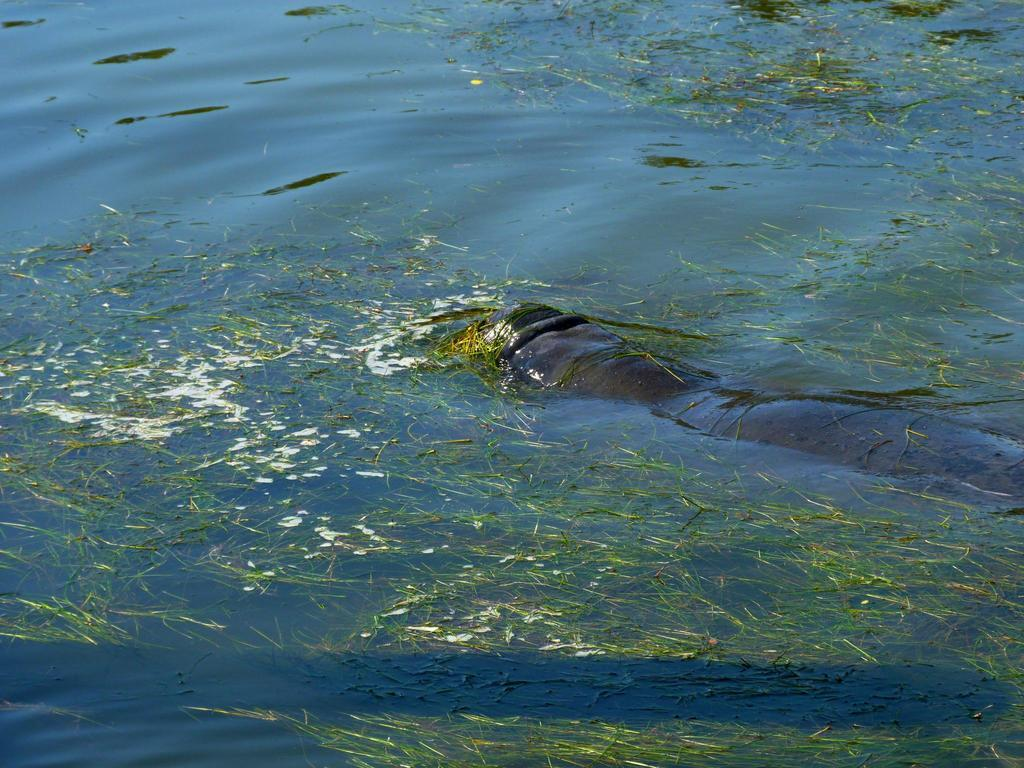What is in the water in the image? There is an animal in the water. What else can be seen floating on the water? There are green leaves floating on the water. What actor is performing in the water in the image? There is no actor present in the image; it features an animal in the water and green leaves floating on it. Can you tell me the direction of the flight in the image? There is no flight present in the image; it only shows an animal in the water and green leaves floating on it. 